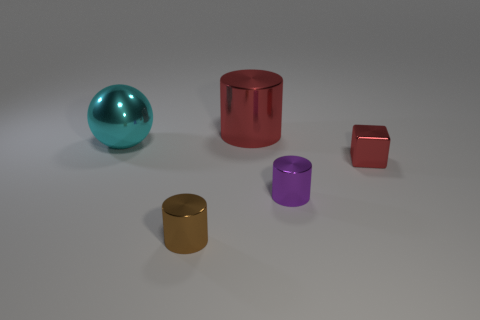There is a shiny cube; does it have the same color as the large shiny object right of the small brown object?
Your answer should be very brief. Yes. There is a tiny metal thing that is the same color as the big shiny cylinder; what shape is it?
Ensure brevity in your answer.  Cube. What shape is the large cyan shiny object?
Ensure brevity in your answer.  Sphere. Is the color of the metallic block the same as the large cylinder?
Keep it short and to the point. Yes. How many things are metal objects behind the small brown cylinder or tiny purple balls?
Your answer should be compact. 4. What size is the ball that is the same material as the purple object?
Provide a short and direct response. Large. Is the number of large objects that are behind the cyan thing greater than the number of large gray balls?
Provide a short and direct response. Yes. There is a big red metal thing; is its shape the same as the small metallic object to the left of the purple metallic cylinder?
Provide a short and direct response. Yes. How many tiny things are either cyan blocks or cyan things?
Offer a very short reply. 0. There is a metal block that is the same color as the large metal cylinder; what is its size?
Your answer should be very brief. Small. 